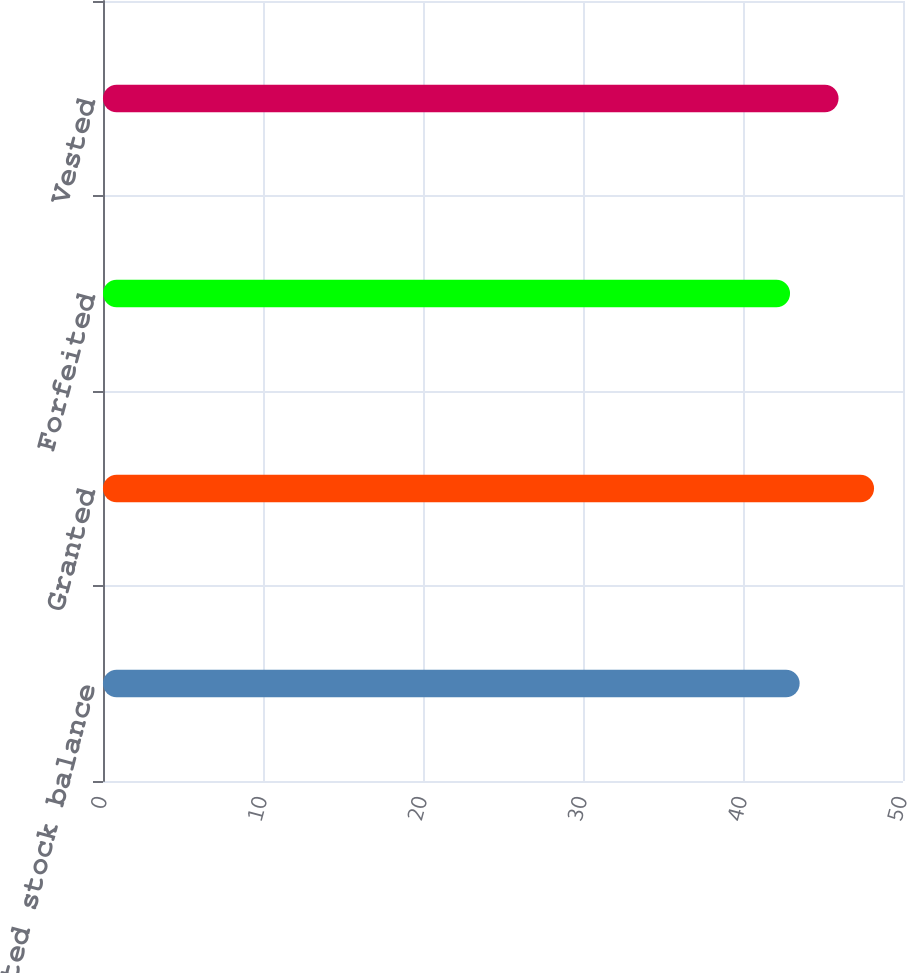Convert chart. <chart><loc_0><loc_0><loc_500><loc_500><bar_chart><fcel>Restricted stock balance<fcel>Granted<fcel>Forfeited<fcel>Vested<nl><fcel>43.54<fcel>48.19<fcel>42.94<fcel>45.97<nl></chart> 